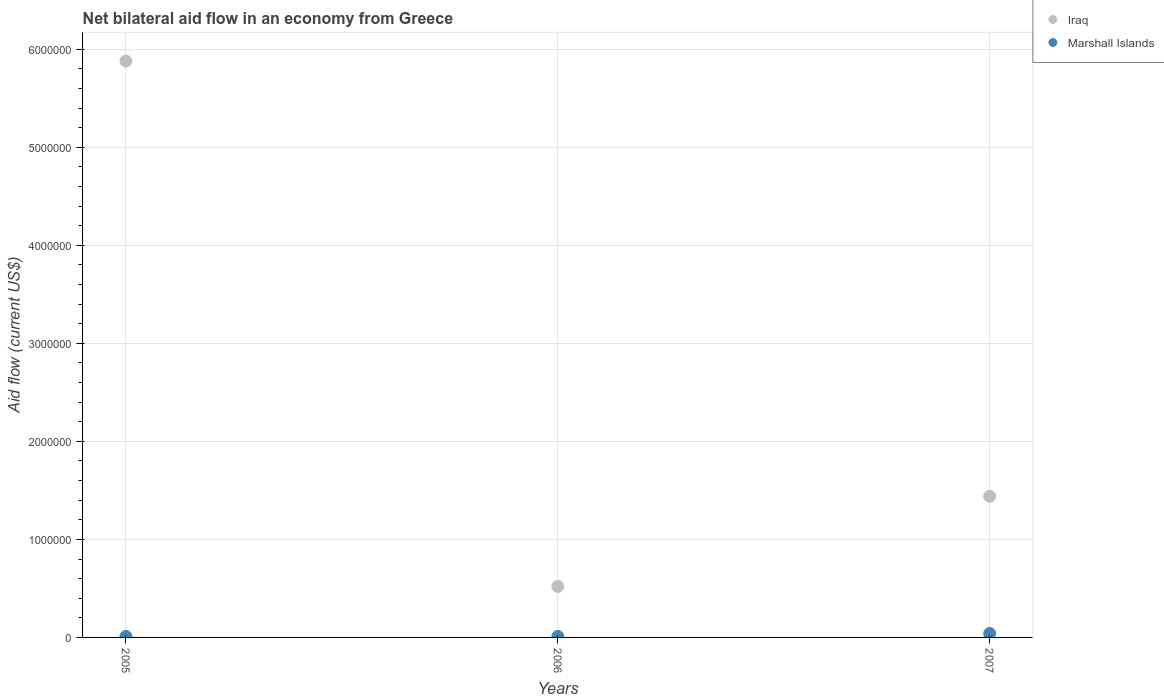How many different coloured dotlines are there?
Make the answer very short. 2. Is the number of dotlines equal to the number of legend labels?
Your answer should be compact. Yes. Across all years, what is the maximum net bilateral aid flow in Marshall Islands?
Make the answer very short. 4.00e+04. Across all years, what is the minimum net bilateral aid flow in Iraq?
Give a very brief answer. 5.20e+05. In which year was the net bilateral aid flow in Iraq maximum?
Your response must be concise. 2005. What is the difference between the net bilateral aid flow in Iraq in 2006 and that in 2007?
Give a very brief answer. -9.20e+05. What is the average net bilateral aid flow in Iraq per year?
Give a very brief answer. 2.61e+06. In the year 2007, what is the difference between the net bilateral aid flow in Iraq and net bilateral aid flow in Marshall Islands?
Your response must be concise. 1.40e+06. In how many years, is the net bilateral aid flow in Iraq greater than 1200000 US$?
Your answer should be very brief. 2. What is the ratio of the net bilateral aid flow in Marshall Islands in 2005 to that in 2006?
Keep it short and to the point. 1. Is the net bilateral aid flow in Iraq in 2005 less than that in 2007?
Give a very brief answer. No. Is the difference between the net bilateral aid flow in Iraq in 2005 and 2007 greater than the difference between the net bilateral aid flow in Marshall Islands in 2005 and 2007?
Offer a very short reply. Yes. What is the difference between the highest and the second highest net bilateral aid flow in Iraq?
Your answer should be very brief. 4.44e+06. What is the difference between the highest and the lowest net bilateral aid flow in Iraq?
Provide a succinct answer. 5.36e+06. Does the net bilateral aid flow in Marshall Islands monotonically increase over the years?
Offer a terse response. No. Is the net bilateral aid flow in Iraq strictly greater than the net bilateral aid flow in Marshall Islands over the years?
Your answer should be compact. Yes. How many dotlines are there?
Keep it short and to the point. 2. What is the difference between two consecutive major ticks on the Y-axis?
Your answer should be compact. 1.00e+06. Does the graph contain any zero values?
Provide a succinct answer. No. Where does the legend appear in the graph?
Ensure brevity in your answer.  Top right. How many legend labels are there?
Provide a short and direct response. 2. How are the legend labels stacked?
Offer a very short reply. Vertical. What is the title of the graph?
Offer a terse response. Net bilateral aid flow in an economy from Greece. What is the label or title of the X-axis?
Provide a short and direct response. Years. What is the label or title of the Y-axis?
Your answer should be compact. Aid flow (current US$). What is the Aid flow (current US$) in Iraq in 2005?
Offer a terse response. 5.88e+06. What is the Aid flow (current US$) in Iraq in 2006?
Offer a terse response. 5.20e+05. What is the Aid flow (current US$) of Marshall Islands in 2006?
Offer a very short reply. 10000. What is the Aid flow (current US$) of Iraq in 2007?
Your answer should be compact. 1.44e+06. What is the Aid flow (current US$) in Marshall Islands in 2007?
Your response must be concise. 4.00e+04. Across all years, what is the maximum Aid flow (current US$) in Iraq?
Provide a short and direct response. 5.88e+06. Across all years, what is the minimum Aid flow (current US$) of Iraq?
Keep it short and to the point. 5.20e+05. What is the total Aid flow (current US$) in Iraq in the graph?
Your answer should be compact. 7.84e+06. What is the total Aid flow (current US$) in Marshall Islands in the graph?
Ensure brevity in your answer.  6.00e+04. What is the difference between the Aid flow (current US$) in Iraq in 2005 and that in 2006?
Your response must be concise. 5.36e+06. What is the difference between the Aid flow (current US$) in Marshall Islands in 2005 and that in 2006?
Offer a terse response. 0. What is the difference between the Aid flow (current US$) of Iraq in 2005 and that in 2007?
Your answer should be compact. 4.44e+06. What is the difference between the Aid flow (current US$) of Iraq in 2006 and that in 2007?
Your answer should be compact. -9.20e+05. What is the difference between the Aid flow (current US$) of Iraq in 2005 and the Aid flow (current US$) of Marshall Islands in 2006?
Provide a succinct answer. 5.87e+06. What is the difference between the Aid flow (current US$) of Iraq in 2005 and the Aid flow (current US$) of Marshall Islands in 2007?
Keep it short and to the point. 5.84e+06. What is the difference between the Aid flow (current US$) of Iraq in 2006 and the Aid flow (current US$) of Marshall Islands in 2007?
Provide a short and direct response. 4.80e+05. What is the average Aid flow (current US$) of Iraq per year?
Your response must be concise. 2.61e+06. What is the average Aid flow (current US$) in Marshall Islands per year?
Your answer should be very brief. 2.00e+04. In the year 2005, what is the difference between the Aid flow (current US$) of Iraq and Aid flow (current US$) of Marshall Islands?
Your response must be concise. 5.87e+06. In the year 2006, what is the difference between the Aid flow (current US$) of Iraq and Aid flow (current US$) of Marshall Islands?
Your answer should be compact. 5.10e+05. In the year 2007, what is the difference between the Aid flow (current US$) of Iraq and Aid flow (current US$) of Marshall Islands?
Offer a terse response. 1.40e+06. What is the ratio of the Aid flow (current US$) of Iraq in 2005 to that in 2006?
Your response must be concise. 11.31. What is the ratio of the Aid flow (current US$) of Iraq in 2005 to that in 2007?
Offer a terse response. 4.08. What is the ratio of the Aid flow (current US$) in Iraq in 2006 to that in 2007?
Your answer should be very brief. 0.36. What is the difference between the highest and the second highest Aid flow (current US$) in Iraq?
Provide a short and direct response. 4.44e+06. What is the difference between the highest and the second highest Aid flow (current US$) in Marshall Islands?
Provide a short and direct response. 3.00e+04. What is the difference between the highest and the lowest Aid flow (current US$) of Iraq?
Offer a very short reply. 5.36e+06. 